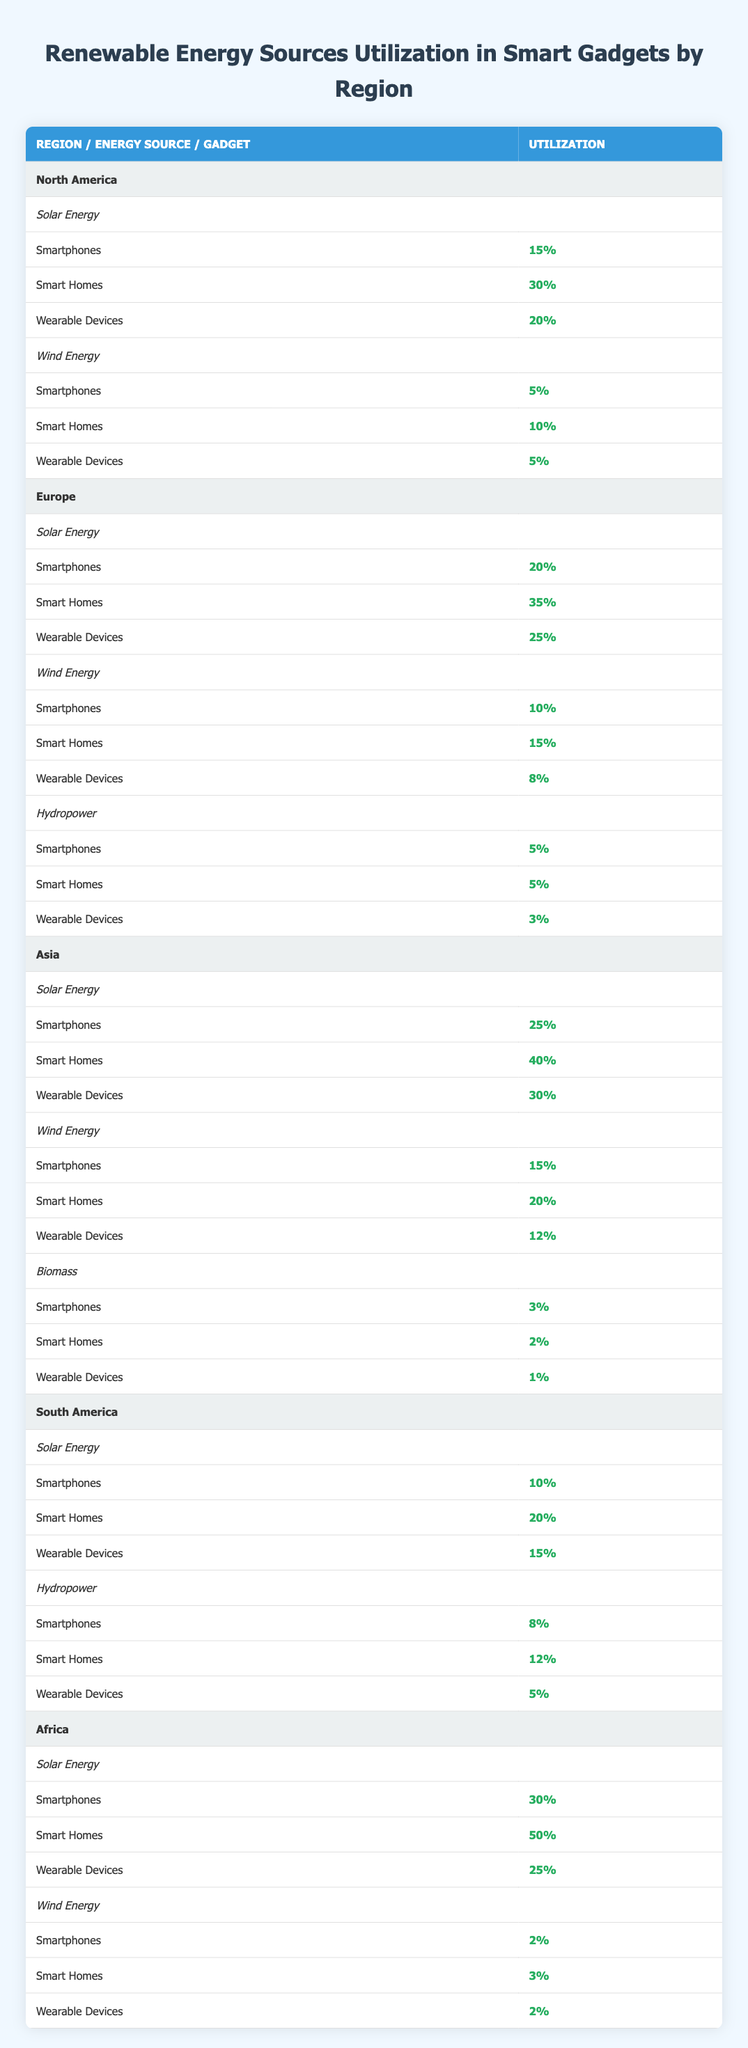What is the solar energy utilization percentage for smart homes in Asia? The table shows that in Asia, smart homes utilize solar energy at a rate of 40%. This percentage can be found directly under the solar energy section for the Asia region.
Answer: 40% What is the average utilization of solar energy in smartphones across North America and Europe? First, we need to find the percentages for solar energy in smartphones for both regions: North America is 15% and Europe is 20%. Next, we sum these values: 15% + 20% = 35%. Then, we calculate the average: 35% / 2 = 17.5%.
Answer: 17.5% Is the utilization of wind energy in smartphones higher in Europe than in North America? For Europe, the utilization of wind energy in smartphones is 10%, while in North America it is 5%. Since 10% is greater than 5%, we confirm that Europe has a higher percentage.
Answer: Yes In which region are wearable devices using the highest percentage of solar energy? The table indicates that in Asia, wearable devices utilize solar energy at a rate of 30%, which is the highest percentage when comparing all regions for wearable devices under solar energy.
Answer: Asia What is the total percentage of renewable energy utilization for smartphones in Africa? Under the Africa section, the table lists solar energy utilization for smartphones as 30% and wind energy as 2%. Adding these values gives 30% + 2% = 32%. There are no other renewable energy sources listed for smartphones in Africa, so the total is 32%.
Answer: 32% How does the utilization of hydropower in smart homes compare between South America and Europe? In Europe, hydropower utilization in smart homes is 5%, while in South America, it is 12%. Comparing these values shows that South America has a higher percentage of hydropower utilization in smart homes than Europe.
Answer: South America What is the total percentage of energy utilization for wearable devices in Europe? In Europe, the table shows the following renewable energy sources and their utilization for wearable devices: solar energy is 25%, wind energy is 8%, and hydropower is 3%. Adding these together gives a total of 25% + 8% + 3% = 36%.
Answer: 36% Is there a renewable energy source that sees utilization in smart homes across all regions? By examining the table, we find that solar energy is utilized in smart homes across all regions (North America, Europe, Asia, South America, and Africa), while wind energy and hydropower do not appear in each region for smart homes. This confirms that solar energy is the only source utilized in every region.
Answer: Yes What is the difference in wearable device utilization between solar energy in Africa and Asia? From the table, solar energy utilization for wearable devices is 25% in Africa and 30% in Asia. The difference is calculated as 30% - 25% = 5%. Therefore, solar energy utilization is higher in Asia by 5%.
Answer: 5% 